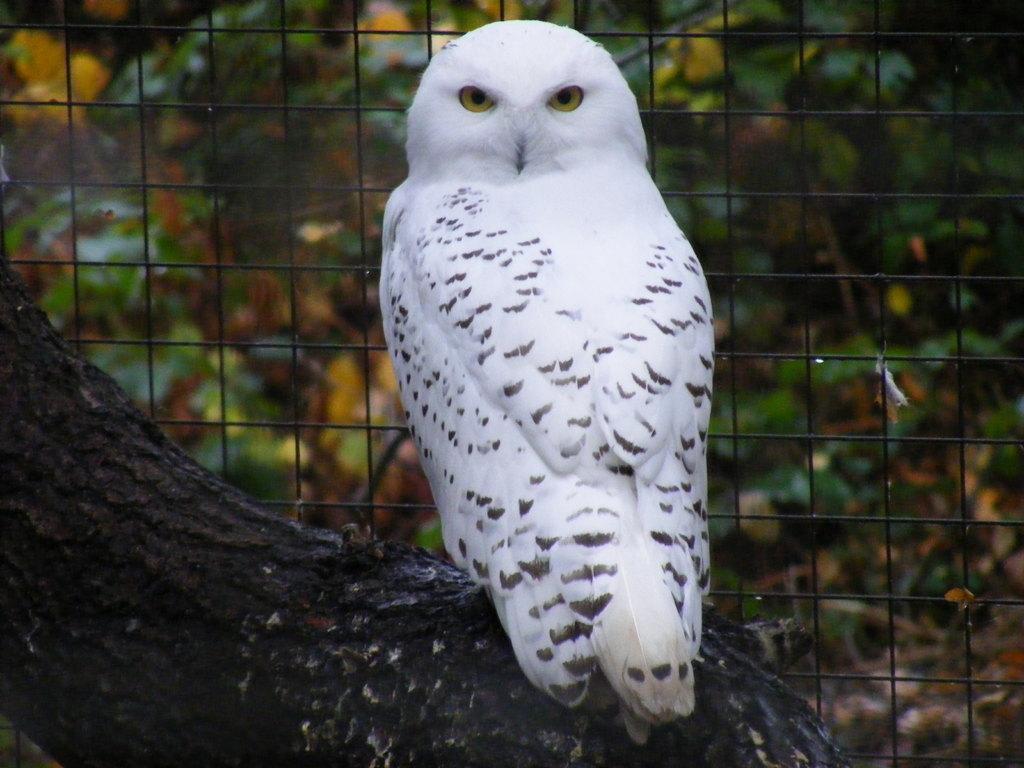Can you describe this image briefly? In this image there is a tree trunk towards the bottom of the image, there is a white owl, there is a fence, at the background of the image there are trees. 